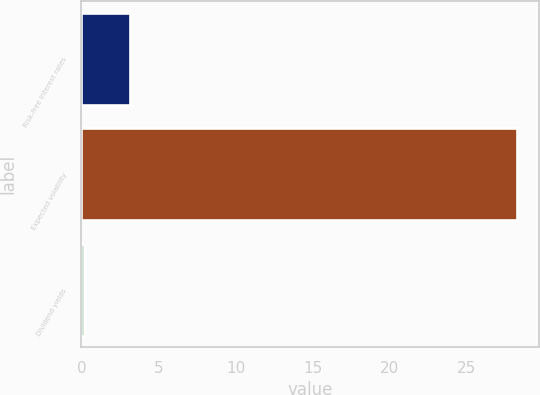Convert chart. <chart><loc_0><loc_0><loc_500><loc_500><bar_chart><fcel>Risk-free interest rates<fcel>Expected volatility<fcel>Dividend yields<nl><fcel>3.15<fcel>28.27<fcel>0.19<nl></chart> 